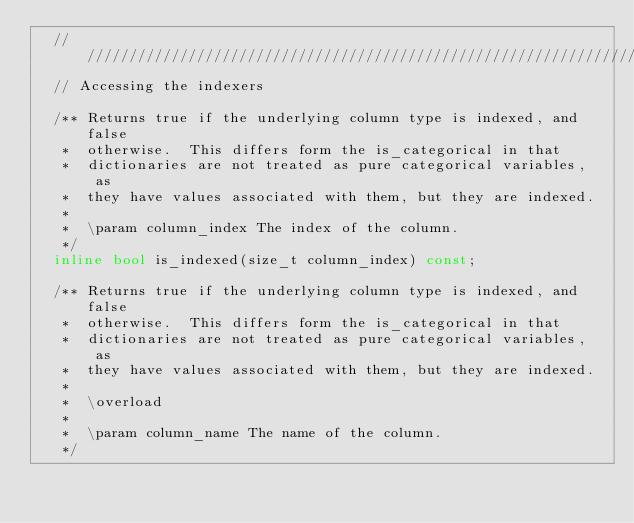<code> <loc_0><loc_0><loc_500><loc_500><_C++_>  ////////////////////////////////////////////////////////////////////////////////
  // Accessing the indexers 

  /** Returns true if the underlying column type is indexed, and false
   *  otherwise.  This differs form the is_categorical in that
   *  dictionaries are not treated as pure categorical variables, as
   *  they have values associated with them, but they are indexed.
   *
   *  \param column_index The index of the column. 
   */
  inline bool is_indexed(size_t column_index) const;

  /** Returns true if the underlying column type is indexed, and false
   *  otherwise.  This differs form the is_categorical in that
   *  dictionaries are not treated as pure categorical variables, as
   *  they have values associated with them, but they are indexed.
   *
   *  \overload
   *
   *  \param column_name The name of the column. 
   */</code> 